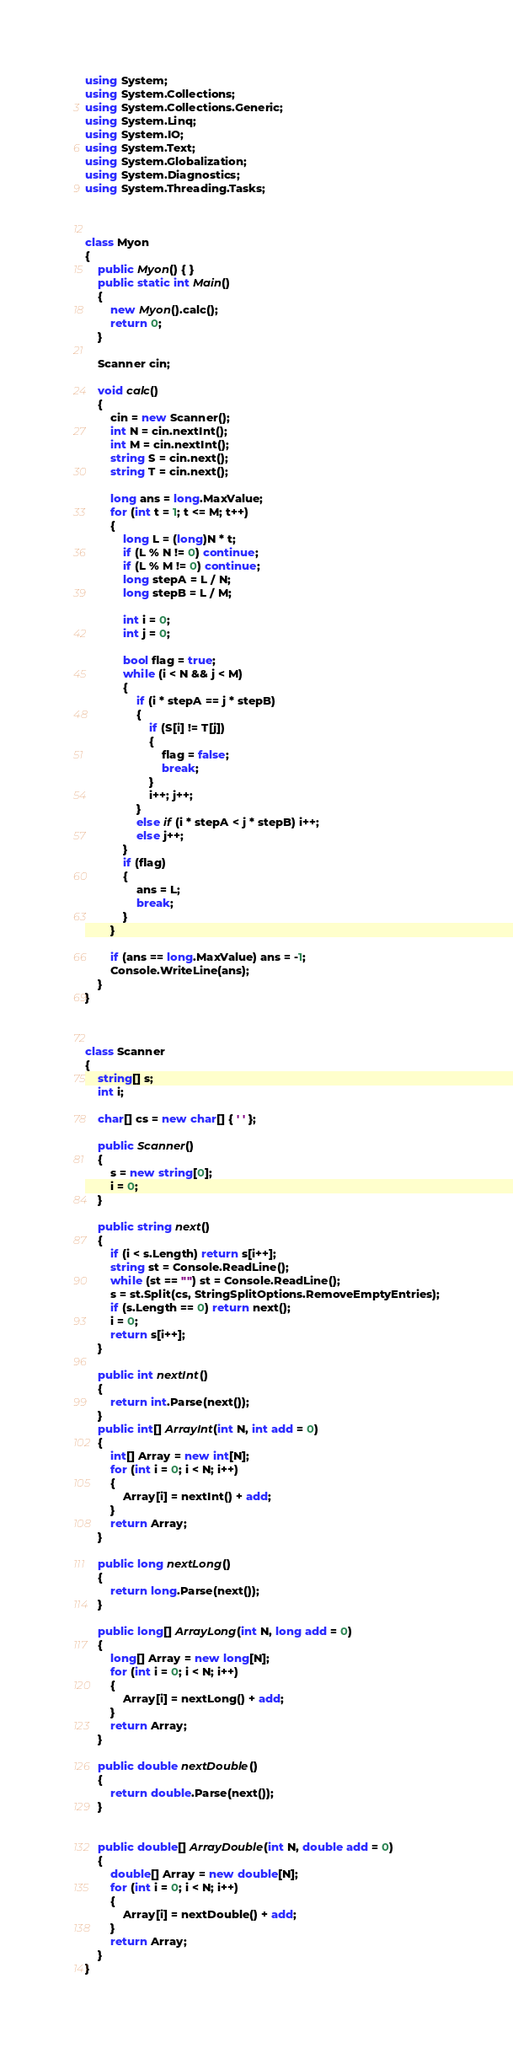Convert code to text. <code><loc_0><loc_0><loc_500><loc_500><_C#_>using System;
using System.Collections;
using System.Collections.Generic;
using System.Linq;
using System.IO;
using System.Text;
using System.Globalization;
using System.Diagnostics;
using System.Threading.Tasks;



class Myon
{
    public Myon() { }
    public static int Main()
    {
        new Myon().calc();
        return 0;
    }

    Scanner cin;

    void calc()
    {
        cin = new Scanner();
        int N = cin.nextInt();
        int M = cin.nextInt();
        string S = cin.next();
        string T = cin.next();

        long ans = long.MaxValue;
        for (int t = 1; t <= M; t++)
        {
            long L = (long)N * t;
            if (L % N != 0) continue;
            if (L % M != 0) continue;
            long stepA = L / N;
            long stepB = L / M;

            int i = 0;
            int j = 0;

            bool flag = true;
            while (i < N && j < M)
            {
                if (i * stepA == j * stepB)
                {
                    if (S[i] != T[j])
                    {
                        flag = false;
                        break;
                    }
                    i++; j++;
                }
                else if (i * stepA < j * stepB) i++;
                else j++;
            }
            if (flag)
            {
                ans = L;
                break;
            }
        }

        if (ans == long.MaxValue) ans = -1;
        Console.WriteLine(ans);
    }
}



class Scanner
{
    string[] s;
    int i;

    char[] cs = new char[] { ' ' };

    public Scanner()
    {
        s = new string[0];
        i = 0;
    }

    public string next()
    {
        if (i < s.Length) return s[i++];
        string st = Console.ReadLine();
        while (st == "") st = Console.ReadLine();
        s = st.Split(cs, StringSplitOptions.RemoveEmptyEntries);
        if (s.Length == 0) return next();
        i = 0;
        return s[i++];
    }

    public int nextInt()
    {
        return int.Parse(next());
    }
    public int[] ArrayInt(int N, int add = 0)
    {
        int[] Array = new int[N];
        for (int i = 0; i < N; i++)
        {
            Array[i] = nextInt() + add;
        }
        return Array;
    }

    public long nextLong()
    {
        return long.Parse(next());
    }

    public long[] ArrayLong(int N, long add = 0)
    {
        long[] Array = new long[N];
        for (int i = 0; i < N; i++)
        {
            Array[i] = nextLong() + add;
        }
        return Array;
    }

    public double nextDouble()
    {
        return double.Parse(next());
    }


    public double[] ArrayDouble(int N, double add = 0)
    {
        double[] Array = new double[N];
        for (int i = 0; i < N; i++)
        {
            Array[i] = nextDouble() + add;
        }
        return Array;
    }
}

</code> 